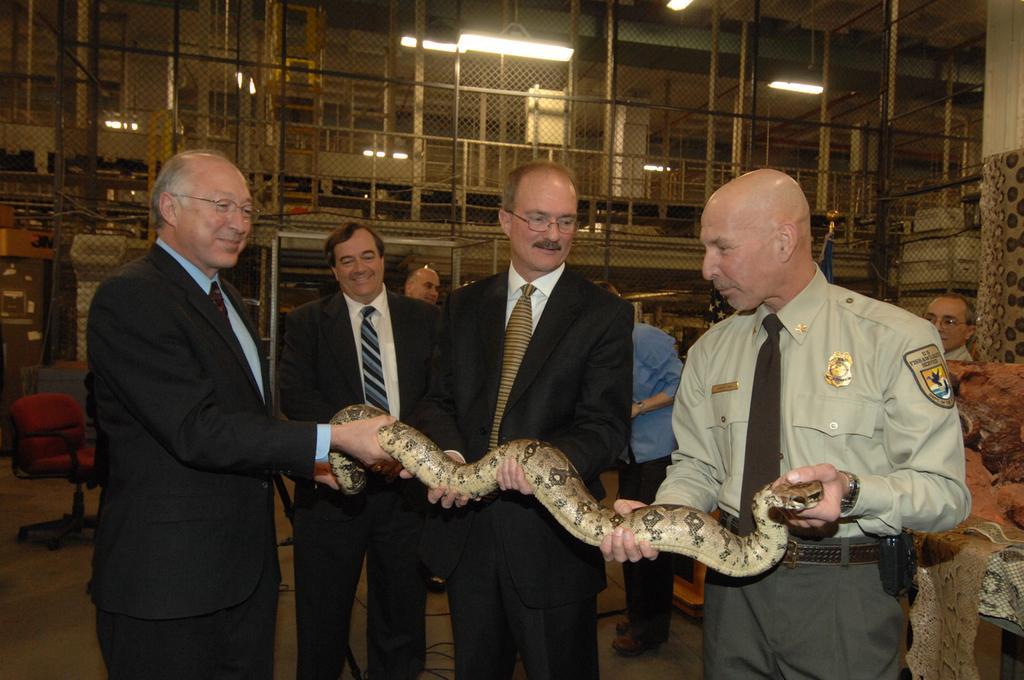Describe this image in one or two sentences. In the foreground of the image there are people standing wearing suits and holding snake in their hands. In the background of the image there is fencing. There are rods,lights. To the left side of the image there is a chair. 